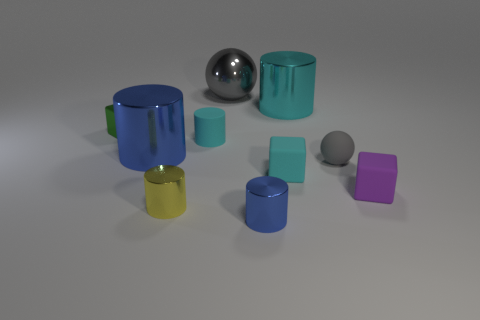What material is the other sphere that is the same color as the small sphere?
Provide a short and direct response. Metal. Are there any yellow objects of the same shape as the green metal thing?
Your answer should be compact. No. What number of green things are either spheres or metal blocks?
Offer a very short reply. 1. Are there any metallic cylinders of the same size as the green metal thing?
Provide a short and direct response. Yes. How many cyan cylinders are there?
Make the answer very short. 2. What number of big things are cyan metallic cylinders or blue shiny objects?
Offer a very short reply. 2. There is a object that is behind the cyan cylinder that is behind the cube behind the small cyan matte cylinder; what color is it?
Your response must be concise. Gray. What number of other things are there of the same color as the large shiny ball?
Provide a short and direct response. 1. What number of matte things are big brown cylinders or small cyan blocks?
Offer a very short reply. 1. Do the small metal object that is behind the purple rubber object and the small metallic cylinder behind the small blue shiny cylinder have the same color?
Offer a very short reply. No. 